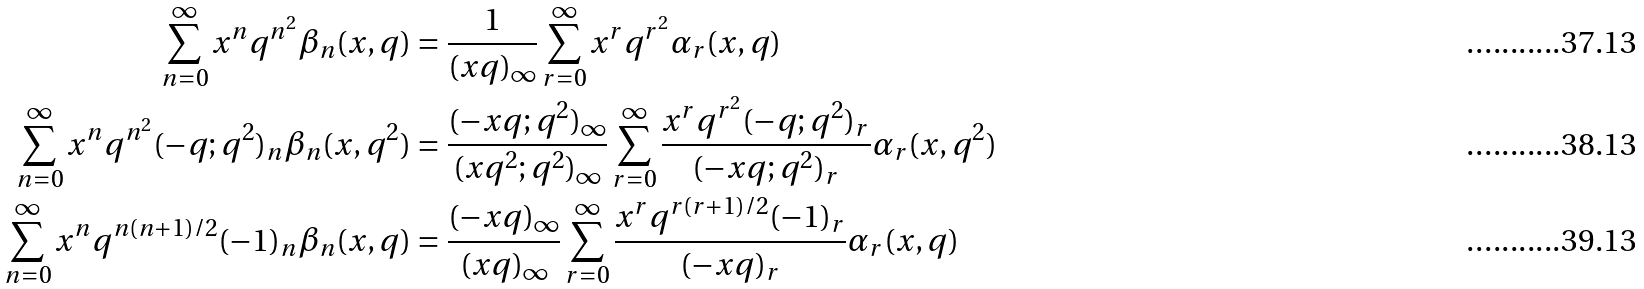<formula> <loc_0><loc_0><loc_500><loc_500>\sum _ { n = 0 } ^ { \infty } x ^ { n } q ^ { n ^ { 2 } } \beta _ { n } ( x , q ) & = \frac { 1 } { ( x q ) _ { \infty } } \sum _ { r = 0 } ^ { \infty } x ^ { r } q ^ { r ^ { 2 } } \alpha _ { r } ( x , q ) \\ \sum _ { n = 0 } ^ { \infty } x ^ { n } q ^ { n ^ { 2 } } ( - q ; q ^ { 2 } ) _ { n } \beta _ { n } ( x , q ^ { 2 } ) & = \frac { ( - x q ; q ^ { 2 } ) _ { \infty } } { ( x q ^ { 2 } ; q ^ { 2 } ) _ { \infty } } \sum _ { r = 0 } ^ { \infty } \frac { x ^ { r } q ^ { r ^ { 2 } } ( - q ; q ^ { 2 } ) _ { r } } { ( - x q ; q ^ { 2 } ) _ { r } } \alpha _ { r } ( x , q ^ { 2 } ) \\ \sum _ { n = 0 } ^ { \infty } x ^ { n } q ^ { n ( n + 1 ) / 2 } ( - 1 ) _ { n } \beta _ { n } ( x , q ) & = \frac { ( - x q ) _ { \infty } } { ( x q ) _ { \infty } } \sum _ { r = 0 } ^ { \infty } \frac { x ^ { r } q ^ { r ( r + 1 ) / 2 } ( - 1 ) _ { r } } { ( - x q ) _ { r } } \alpha _ { r } ( x , q )</formula> 